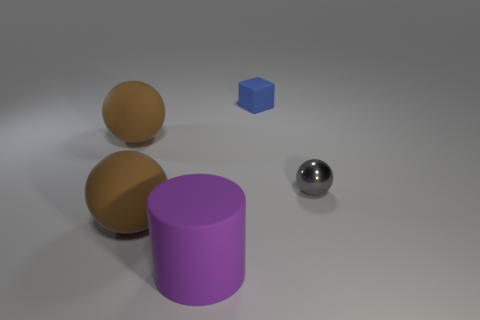Add 3 large things. How many objects exist? 8 Subtract all balls. How many objects are left? 2 Subtract all blue objects. Subtract all tiny metallic balls. How many objects are left? 3 Add 1 blue things. How many blue things are left? 2 Add 1 blocks. How many blocks exist? 2 Subtract 1 blue cubes. How many objects are left? 4 